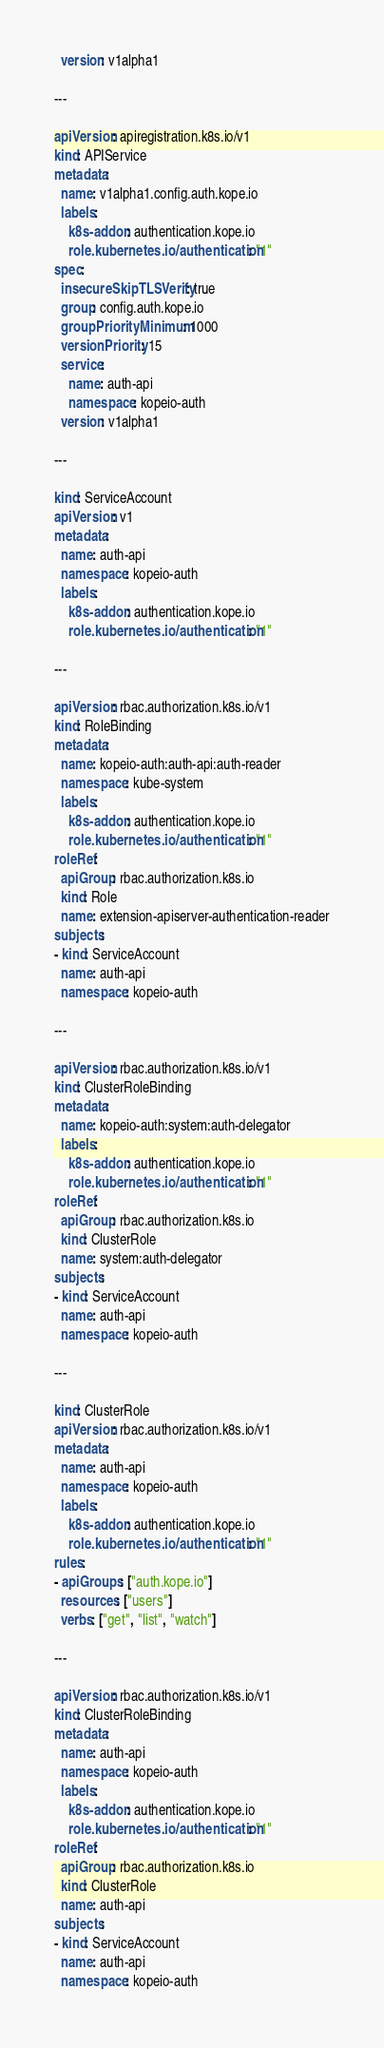Convert code to text. <code><loc_0><loc_0><loc_500><loc_500><_YAML_>  version: v1alpha1

---

apiVersion: apiregistration.k8s.io/v1
kind: APIService
metadata:
  name: v1alpha1.config.auth.kope.io
  labels:
    k8s-addon: authentication.kope.io
    role.kubernetes.io/authentication: "1"
spec:
  insecureSkipTLSVerify: true
  group: config.auth.kope.io
  groupPriorityMinimum: 1000
  versionPriority: 15
  service:
    name: auth-api
    namespace: kopeio-auth
  version: v1alpha1

---

kind: ServiceAccount
apiVersion: v1
metadata:
  name: auth-api
  namespace: kopeio-auth
  labels:
    k8s-addon: authentication.kope.io
    role.kubernetes.io/authentication: "1"

---

apiVersion: rbac.authorization.k8s.io/v1
kind: RoleBinding
metadata:
  name: kopeio-auth:auth-api:auth-reader
  namespace: kube-system
  labels:
    k8s-addon: authentication.kope.io
    role.kubernetes.io/authentication: "1"
roleRef:
  apiGroup: rbac.authorization.k8s.io
  kind: Role
  name: extension-apiserver-authentication-reader
subjects:
- kind: ServiceAccount
  name: auth-api
  namespace: kopeio-auth

---

apiVersion: rbac.authorization.k8s.io/v1
kind: ClusterRoleBinding
metadata:
  name: kopeio-auth:system:auth-delegator
  labels:
    k8s-addon: authentication.kope.io
    role.kubernetes.io/authentication: "1"
roleRef:
  apiGroup: rbac.authorization.k8s.io
  kind: ClusterRole
  name: system:auth-delegator
subjects:
- kind: ServiceAccount
  name: auth-api
  namespace: kopeio-auth

---

kind: ClusterRole
apiVersion: rbac.authorization.k8s.io/v1
metadata:
  name: auth-api
  namespace: kopeio-auth
  labels:
    k8s-addon: authentication.kope.io
    role.kubernetes.io/authentication: "1"
rules:
- apiGroups: ["auth.kope.io"]
  resources: ["users"]
  verbs: ["get", "list", "watch"]

---

apiVersion: rbac.authorization.k8s.io/v1
kind: ClusterRoleBinding
metadata:
  name: auth-api
  namespace: kopeio-auth
  labels:
    k8s-addon: authentication.kope.io
    role.kubernetes.io/authentication: "1"
roleRef:
  apiGroup: rbac.authorization.k8s.io
  kind: ClusterRole
  name: auth-api
subjects:
- kind: ServiceAccount
  name: auth-api
  namespace: kopeio-auth
</code> 